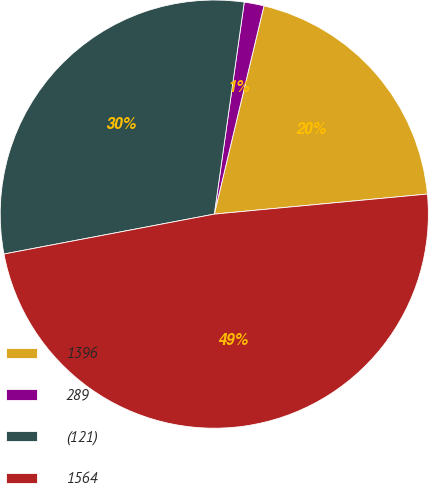<chart> <loc_0><loc_0><loc_500><loc_500><pie_chart><fcel>1396<fcel>289<fcel>(121)<fcel>1564<nl><fcel>19.78%<fcel>1.49%<fcel>30.22%<fcel>48.51%<nl></chart> 